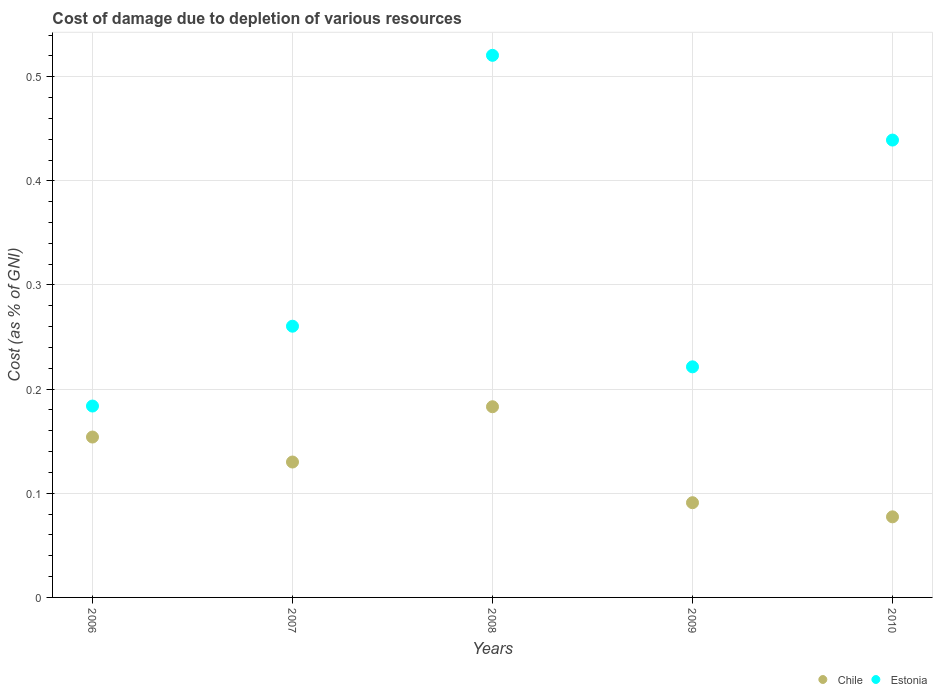How many different coloured dotlines are there?
Ensure brevity in your answer.  2. Is the number of dotlines equal to the number of legend labels?
Keep it short and to the point. Yes. What is the cost of damage caused due to the depletion of various resources in Estonia in 2006?
Provide a short and direct response. 0.18. Across all years, what is the maximum cost of damage caused due to the depletion of various resources in Chile?
Ensure brevity in your answer.  0.18. Across all years, what is the minimum cost of damage caused due to the depletion of various resources in Estonia?
Your answer should be compact. 0.18. In which year was the cost of damage caused due to the depletion of various resources in Estonia maximum?
Keep it short and to the point. 2008. In which year was the cost of damage caused due to the depletion of various resources in Chile minimum?
Keep it short and to the point. 2010. What is the total cost of damage caused due to the depletion of various resources in Estonia in the graph?
Offer a terse response. 1.63. What is the difference between the cost of damage caused due to the depletion of various resources in Chile in 2007 and that in 2008?
Offer a terse response. -0.05. What is the difference between the cost of damage caused due to the depletion of various resources in Chile in 2006 and the cost of damage caused due to the depletion of various resources in Estonia in 2009?
Keep it short and to the point. -0.07. What is the average cost of damage caused due to the depletion of various resources in Chile per year?
Give a very brief answer. 0.13. In the year 2007, what is the difference between the cost of damage caused due to the depletion of various resources in Estonia and cost of damage caused due to the depletion of various resources in Chile?
Offer a very short reply. 0.13. In how many years, is the cost of damage caused due to the depletion of various resources in Estonia greater than 0.2 %?
Keep it short and to the point. 4. What is the ratio of the cost of damage caused due to the depletion of various resources in Chile in 2006 to that in 2007?
Keep it short and to the point. 1.18. Is the cost of damage caused due to the depletion of various resources in Chile in 2007 less than that in 2008?
Your answer should be very brief. Yes. What is the difference between the highest and the second highest cost of damage caused due to the depletion of various resources in Chile?
Make the answer very short. 0.03. What is the difference between the highest and the lowest cost of damage caused due to the depletion of various resources in Estonia?
Provide a succinct answer. 0.34. Is the sum of the cost of damage caused due to the depletion of various resources in Estonia in 2006 and 2008 greater than the maximum cost of damage caused due to the depletion of various resources in Chile across all years?
Your response must be concise. Yes. Does the cost of damage caused due to the depletion of various resources in Estonia monotonically increase over the years?
Offer a very short reply. No. Is the cost of damage caused due to the depletion of various resources in Estonia strictly greater than the cost of damage caused due to the depletion of various resources in Chile over the years?
Your answer should be very brief. Yes. Are the values on the major ticks of Y-axis written in scientific E-notation?
Offer a very short reply. No. Does the graph contain any zero values?
Offer a terse response. No. Does the graph contain grids?
Keep it short and to the point. Yes. Where does the legend appear in the graph?
Your answer should be compact. Bottom right. How many legend labels are there?
Give a very brief answer. 2. How are the legend labels stacked?
Make the answer very short. Horizontal. What is the title of the graph?
Provide a short and direct response. Cost of damage due to depletion of various resources. What is the label or title of the Y-axis?
Keep it short and to the point. Cost (as % of GNI). What is the Cost (as % of GNI) of Chile in 2006?
Give a very brief answer. 0.15. What is the Cost (as % of GNI) in Estonia in 2006?
Offer a terse response. 0.18. What is the Cost (as % of GNI) in Chile in 2007?
Offer a terse response. 0.13. What is the Cost (as % of GNI) of Estonia in 2007?
Ensure brevity in your answer.  0.26. What is the Cost (as % of GNI) in Chile in 2008?
Ensure brevity in your answer.  0.18. What is the Cost (as % of GNI) of Estonia in 2008?
Your response must be concise. 0.52. What is the Cost (as % of GNI) in Chile in 2009?
Offer a terse response. 0.09. What is the Cost (as % of GNI) of Estonia in 2009?
Ensure brevity in your answer.  0.22. What is the Cost (as % of GNI) in Chile in 2010?
Provide a short and direct response. 0.08. What is the Cost (as % of GNI) in Estonia in 2010?
Ensure brevity in your answer.  0.44. Across all years, what is the maximum Cost (as % of GNI) in Chile?
Ensure brevity in your answer.  0.18. Across all years, what is the maximum Cost (as % of GNI) of Estonia?
Give a very brief answer. 0.52. Across all years, what is the minimum Cost (as % of GNI) of Chile?
Provide a succinct answer. 0.08. Across all years, what is the minimum Cost (as % of GNI) of Estonia?
Ensure brevity in your answer.  0.18. What is the total Cost (as % of GNI) in Chile in the graph?
Your answer should be compact. 0.64. What is the total Cost (as % of GNI) in Estonia in the graph?
Your answer should be compact. 1.63. What is the difference between the Cost (as % of GNI) in Chile in 2006 and that in 2007?
Keep it short and to the point. 0.02. What is the difference between the Cost (as % of GNI) in Estonia in 2006 and that in 2007?
Offer a very short reply. -0.08. What is the difference between the Cost (as % of GNI) in Chile in 2006 and that in 2008?
Your answer should be compact. -0.03. What is the difference between the Cost (as % of GNI) of Estonia in 2006 and that in 2008?
Your response must be concise. -0.34. What is the difference between the Cost (as % of GNI) of Chile in 2006 and that in 2009?
Ensure brevity in your answer.  0.06. What is the difference between the Cost (as % of GNI) of Estonia in 2006 and that in 2009?
Make the answer very short. -0.04. What is the difference between the Cost (as % of GNI) in Chile in 2006 and that in 2010?
Offer a very short reply. 0.08. What is the difference between the Cost (as % of GNI) of Estonia in 2006 and that in 2010?
Ensure brevity in your answer.  -0.26. What is the difference between the Cost (as % of GNI) in Chile in 2007 and that in 2008?
Make the answer very short. -0.05. What is the difference between the Cost (as % of GNI) of Estonia in 2007 and that in 2008?
Keep it short and to the point. -0.26. What is the difference between the Cost (as % of GNI) of Chile in 2007 and that in 2009?
Give a very brief answer. 0.04. What is the difference between the Cost (as % of GNI) in Estonia in 2007 and that in 2009?
Keep it short and to the point. 0.04. What is the difference between the Cost (as % of GNI) in Chile in 2007 and that in 2010?
Keep it short and to the point. 0.05. What is the difference between the Cost (as % of GNI) of Estonia in 2007 and that in 2010?
Offer a terse response. -0.18. What is the difference between the Cost (as % of GNI) in Chile in 2008 and that in 2009?
Offer a very short reply. 0.09. What is the difference between the Cost (as % of GNI) in Estonia in 2008 and that in 2009?
Your response must be concise. 0.3. What is the difference between the Cost (as % of GNI) of Chile in 2008 and that in 2010?
Offer a very short reply. 0.11. What is the difference between the Cost (as % of GNI) of Estonia in 2008 and that in 2010?
Offer a very short reply. 0.08. What is the difference between the Cost (as % of GNI) in Chile in 2009 and that in 2010?
Provide a succinct answer. 0.01. What is the difference between the Cost (as % of GNI) of Estonia in 2009 and that in 2010?
Ensure brevity in your answer.  -0.22. What is the difference between the Cost (as % of GNI) in Chile in 2006 and the Cost (as % of GNI) in Estonia in 2007?
Your answer should be compact. -0.11. What is the difference between the Cost (as % of GNI) of Chile in 2006 and the Cost (as % of GNI) of Estonia in 2008?
Your response must be concise. -0.37. What is the difference between the Cost (as % of GNI) in Chile in 2006 and the Cost (as % of GNI) in Estonia in 2009?
Provide a succinct answer. -0.07. What is the difference between the Cost (as % of GNI) in Chile in 2006 and the Cost (as % of GNI) in Estonia in 2010?
Your answer should be very brief. -0.29. What is the difference between the Cost (as % of GNI) of Chile in 2007 and the Cost (as % of GNI) of Estonia in 2008?
Offer a very short reply. -0.39. What is the difference between the Cost (as % of GNI) in Chile in 2007 and the Cost (as % of GNI) in Estonia in 2009?
Offer a very short reply. -0.09. What is the difference between the Cost (as % of GNI) in Chile in 2007 and the Cost (as % of GNI) in Estonia in 2010?
Keep it short and to the point. -0.31. What is the difference between the Cost (as % of GNI) in Chile in 2008 and the Cost (as % of GNI) in Estonia in 2009?
Your answer should be compact. -0.04. What is the difference between the Cost (as % of GNI) of Chile in 2008 and the Cost (as % of GNI) of Estonia in 2010?
Provide a succinct answer. -0.26. What is the difference between the Cost (as % of GNI) of Chile in 2009 and the Cost (as % of GNI) of Estonia in 2010?
Make the answer very short. -0.35. What is the average Cost (as % of GNI) in Chile per year?
Your answer should be compact. 0.13. What is the average Cost (as % of GNI) of Estonia per year?
Your answer should be compact. 0.33. In the year 2006, what is the difference between the Cost (as % of GNI) in Chile and Cost (as % of GNI) in Estonia?
Your answer should be compact. -0.03. In the year 2007, what is the difference between the Cost (as % of GNI) in Chile and Cost (as % of GNI) in Estonia?
Provide a succinct answer. -0.13. In the year 2008, what is the difference between the Cost (as % of GNI) of Chile and Cost (as % of GNI) of Estonia?
Your answer should be very brief. -0.34. In the year 2009, what is the difference between the Cost (as % of GNI) in Chile and Cost (as % of GNI) in Estonia?
Your answer should be very brief. -0.13. In the year 2010, what is the difference between the Cost (as % of GNI) in Chile and Cost (as % of GNI) in Estonia?
Provide a short and direct response. -0.36. What is the ratio of the Cost (as % of GNI) of Chile in 2006 to that in 2007?
Keep it short and to the point. 1.18. What is the ratio of the Cost (as % of GNI) in Estonia in 2006 to that in 2007?
Your answer should be compact. 0.71. What is the ratio of the Cost (as % of GNI) of Chile in 2006 to that in 2008?
Give a very brief answer. 0.84. What is the ratio of the Cost (as % of GNI) in Estonia in 2006 to that in 2008?
Your response must be concise. 0.35. What is the ratio of the Cost (as % of GNI) of Chile in 2006 to that in 2009?
Your answer should be very brief. 1.69. What is the ratio of the Cost (as % of GNI) in Estonia in 2006 to that in 2009?
Your answer should be very brief. 0.83. What is the ratio of the Cost (as % of GNI) in Chile in 2006 to that in 2010?
Make the answer very short. 1.99. What is the ratio of the Cost (as % of GNI) in Estonia in 2006 to that in 2010?
Offer a terse response. 0.42. What is the ratio of the Cost (as % of GNI) in Chile in 2007 to that in 2008?
Provide a succinct answer. 0.71. What is the ratio of the Cost (as % of GNI) of Estonia in 2007 to that in 2008?
Keep it short and to the point. 0.5. What is the ratio of the Cost (as % of GNI) in Chile in 2007 to that in 2009?
Make the answer very short. 1.43. What is the ratio of the Cost (as % of GNI) in Estonia in 2007 to that in 2009?
Provide a succinct answer. 1.18. What is the ratio of the Cost (as % of GNI) of Chile in 2007 to that in 2010?
Your answer should be very brief. 1.68. What is the ratio of the Cost (as % of GNI) of Estonia in 2007 to that in 2010?
Offer a very short reply. 0.59. What is the ratio of the Cost (as % of GNI) of Chile in 2008 to that in 2009?
Your answer should be very brief. 2.01. What is the ratio of the Cost (as % of GNI) in Estonia in 2008 to that in 2009?
Make the answer very short. 2.35. What is the ratio of the Cost (as % of GNI) in Chile in 2008 to that in 2010?
Your response must be concise. 2.37. What is the ratio of the Cost (as % of GNI) of Estonia in 2008 to that in 2010?
Give a very brief answer. 1.19. What is the ratio of the Cost (as % of GNI) of Chile in 2009 to that in 2010?
Offer a terse response. 1.18. What is the ratio of the Cost (as % of GNI) in Estonia in 2009 to that in 2010?
Provide a succinct answer. 0.5. What is the difference between the highest and the second highest Cost (as % of GNI) in Chile?
Keep it short and to the point. 0.03. What is the difference between the highest and the second highest Cost (as % of GNI) in Estonia?
Your answer should be compact. 0.08. What is the difference between the highest and the lowest Cost (as % of GNI) in Chile?
Provide a succinct answer. 0.11. What is the difference between the highest and the lowest Cost (as % of GNI) in Estonia?
Offer a very short reply. 0.34. 